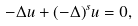<formula> <loc_0><loc_0><loc_500><loc_500>- \Delta u + ( - \Delta ) ^ { s } u = 0 ,</formula> 